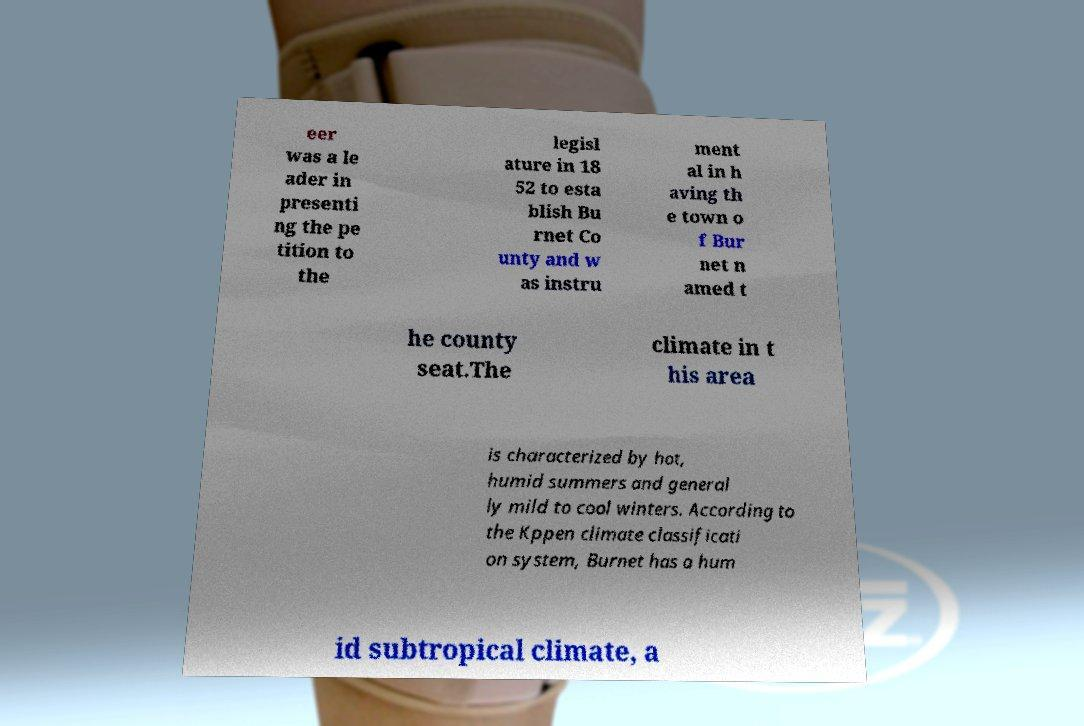Could you extract and type out the text from this image? eer was a le ader in presenti ng the pe tition to the legisl ature in 18 52 to esta blish Bu rnet Co unty and w as instru ment al in h aving th e town o f Bur net n amed t he county seat.The climate in t his area is characterized by hot, humid summers and general ly mild to cool winters. According to the Kppen climate classificati on system, Burnet has a hum id subtropical climate, a 